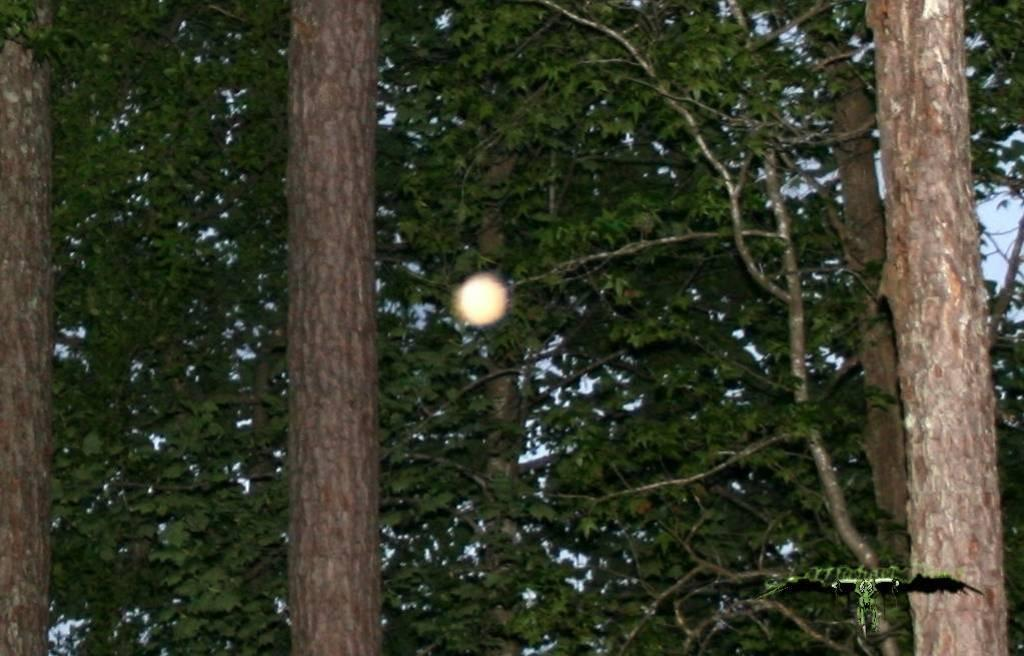What type of vegetation can be seen in the image? There are trees in the image. Is there any text or marking visible in the image? Yes, there is a watermark at the bottom right corner of the image. What type of zipper can be seen on the plants in the image? There are no zippers present on the plants in the image. Can you hear a bell ringing in the image? There is no sound or indication of a bell in the image. 